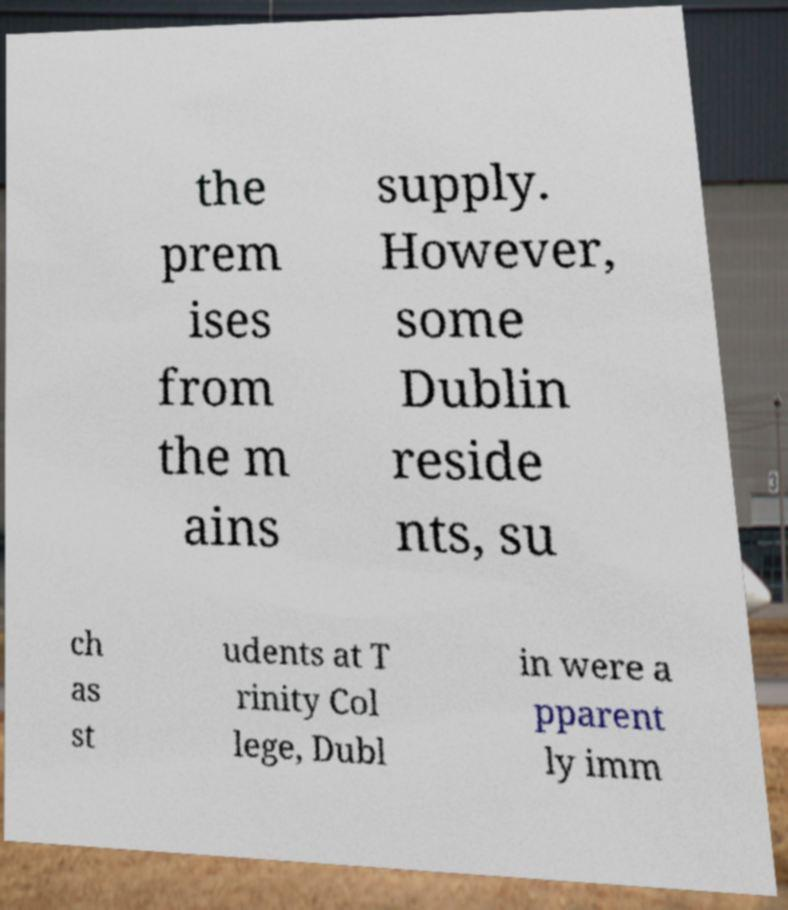Could you extract and type out the text from this image? the prem ises from the m ains supply. However, some Dublin reside nts, su ch as st udents at T rinity Col lege, Dubl in were a pparent ly imm 